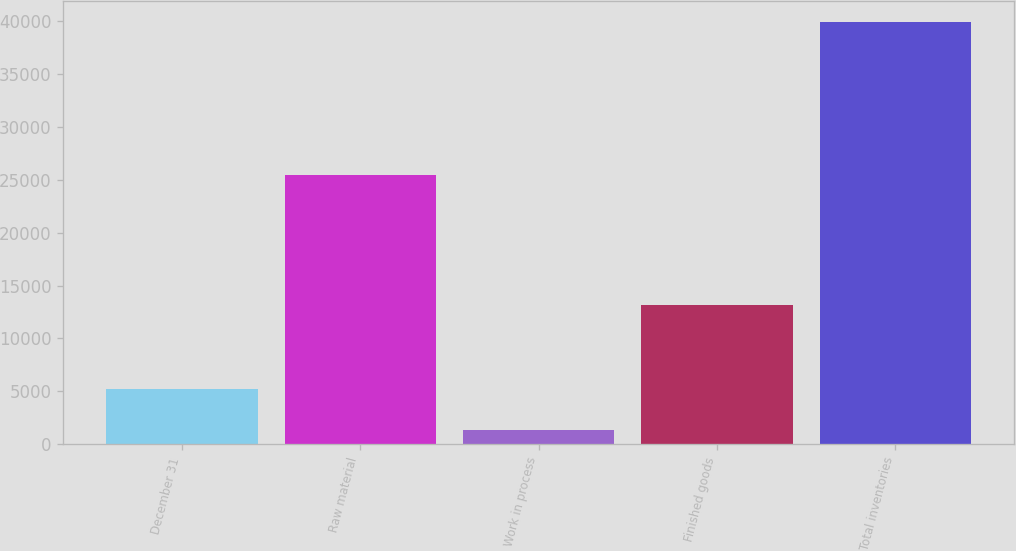Convert chart. <chart><loc_0><loc_0><loc_500><loc_500><bar_chart><fcel>December 31<fcel>Raw material<fcel>Work in process<fcel>Finished goods<fcel>Total inventories<nl><fcel>5216.3<fcel>25410<fcel>1360<fcel>13153<fcel>39923<nl></chart> 